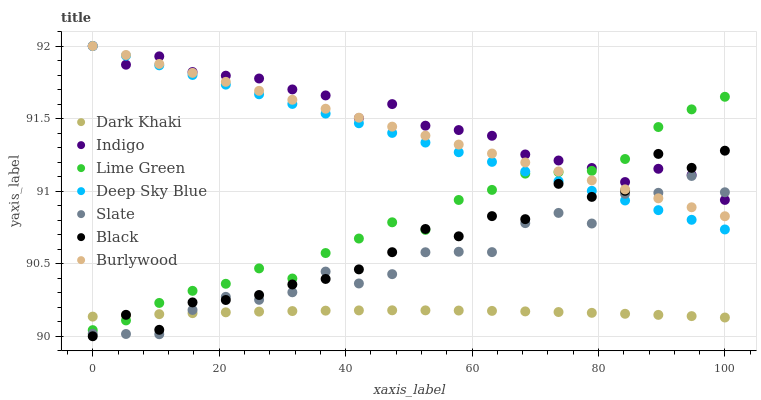Does Dark Khaki have the minimum area under the curve?
Answer yes or no. Yes. Does Indigo have the maximum area under the curve?
Answer yes or no. Yes. Does Burlywood have the minimum area under the curve?
Answer yes or no. No. Does Burlywood have the maximum area under the curve?
Answer yes or no. No. Is Burlywood the smoothest?
Answer yes or no. Yes. Is Black the roughest?
Answer yes or no. Yes. Is Slate the smoothest?
Answer yes or no. No. Is Slate the roughest?
Answer yes or no. No. Does Black have the lowest value?
Answer yes or no. Yes. Does Burlywood have the lowest value?
Answer yes or no. No. Does Deep Sky Blue have the highest value?
Answer yes or no. Yes. Does Slate have the highest value?
Answer yes or no. No. Is Dark Khaki less than Indigo?
Answer yes or no. Yes. Is Indigo greater than Dark Khaki?
Answer yes or no. Yes. Does Burlywood intersect Black?
Answer yes or no. Yes. Is Burlywood less than Black?
Answer yes or no. No. Is Burlywood greater than Black?
Answer yes or no. No. Does Dark Khaki intersect Indigo?
Answer yes or no. No. 